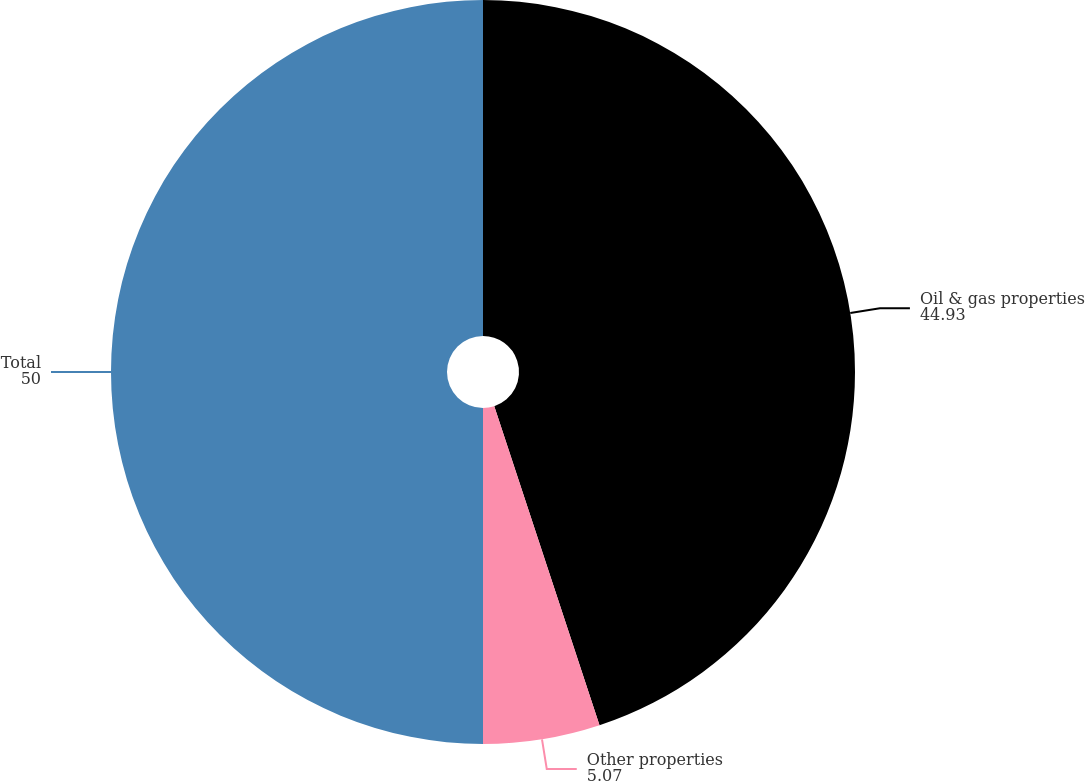<chart> <loc_0><loc_0><loc_500><loc_500><pie_chart><fcel>Oil & gas properties<fcel>Other properties<fcel>Total<nl><fcel>44.93%<fcel>5.07%<fcel>50.0%<nl></chart> 